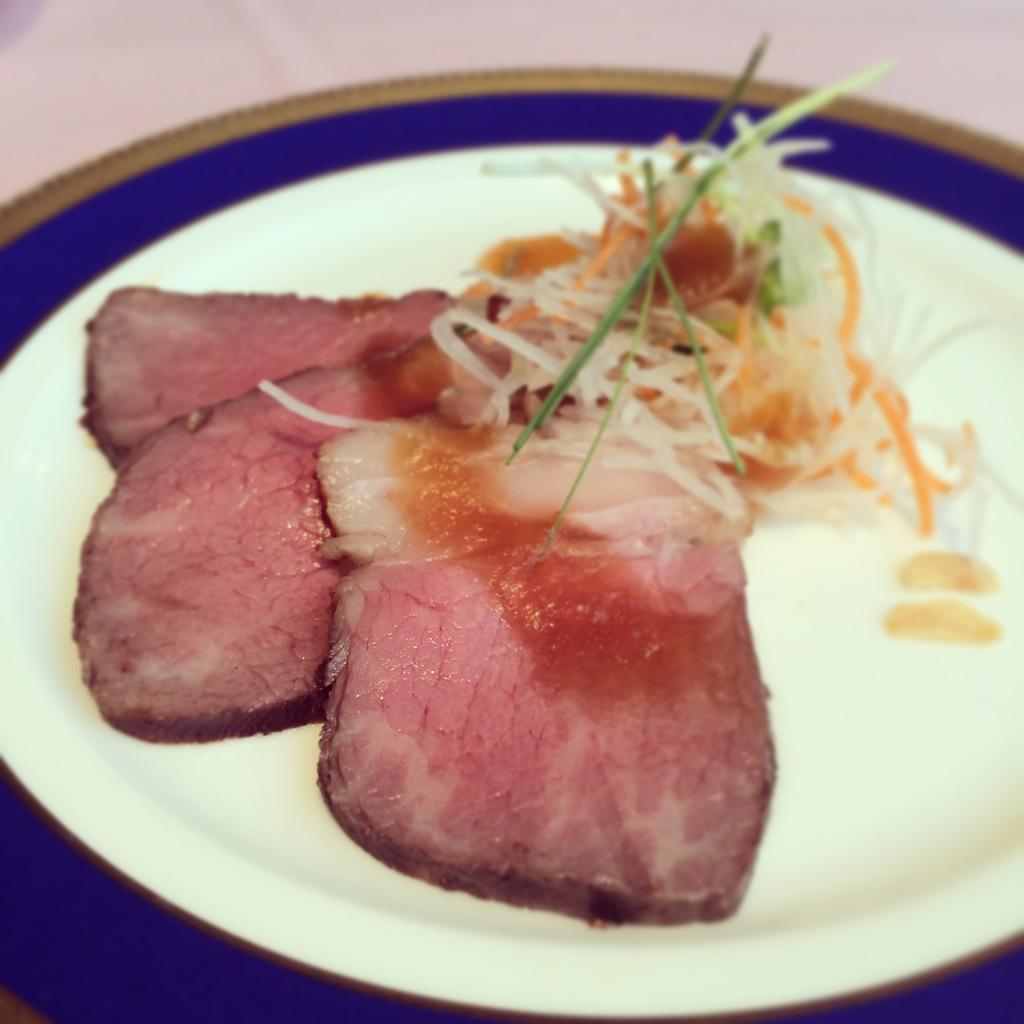What type of food can be seen in the image? There is cooked meat in the image. What is the cooked meat placed on? There is a food item in the plate. What type of straw can be seen in the image? There is no straw present in the image. What type of thunder can be heard in the image? The image is a still image, so there is no sound, including thunder, present. 